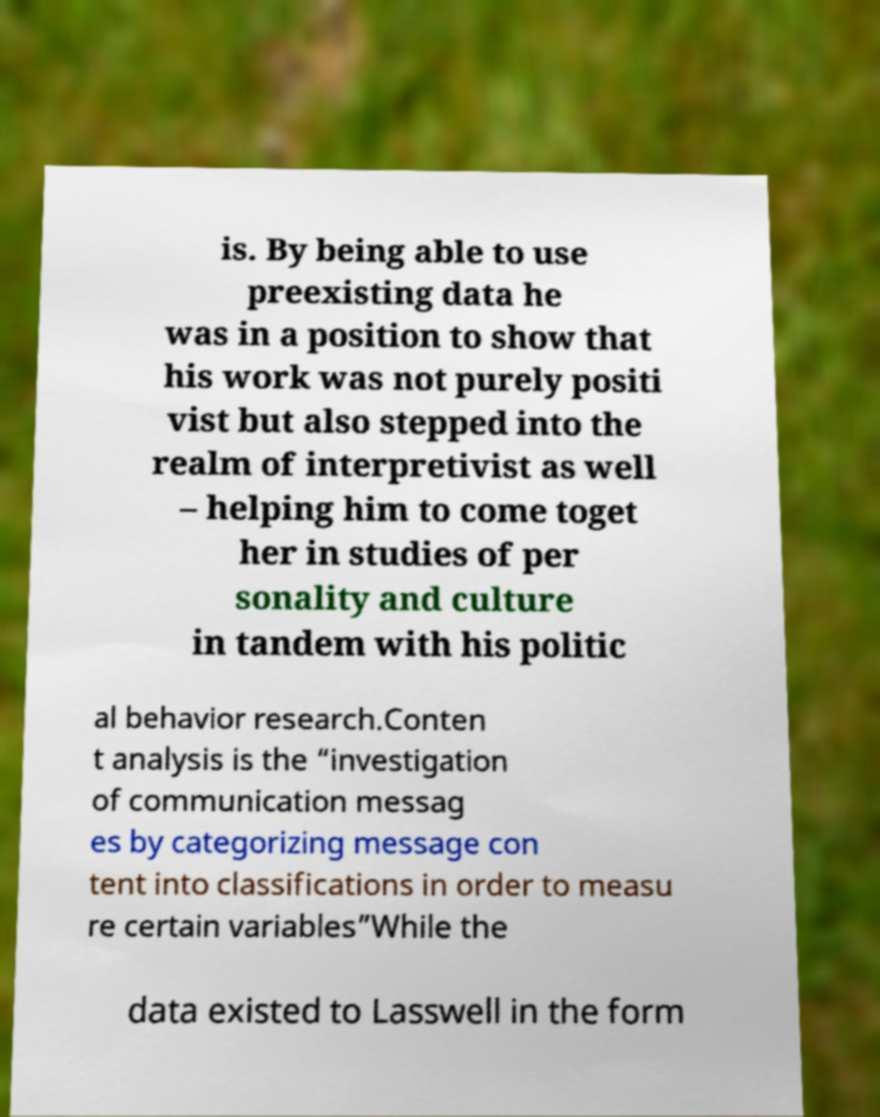Can you accurately transcribe the text from the provided image for me? is. By being able to use preexisting data he was in a position to show that his work was not purely positi vist but also stepped into the realm of interpretivist as well – helping him to come toget her in studies of per sonality and culture in tandem with his politic al behavior research.Conten t analysis is the “investigation of communication messag es by categorizing message con tent into classifications in order to measu re certain variables”While the data existed to Lasswell in the form 